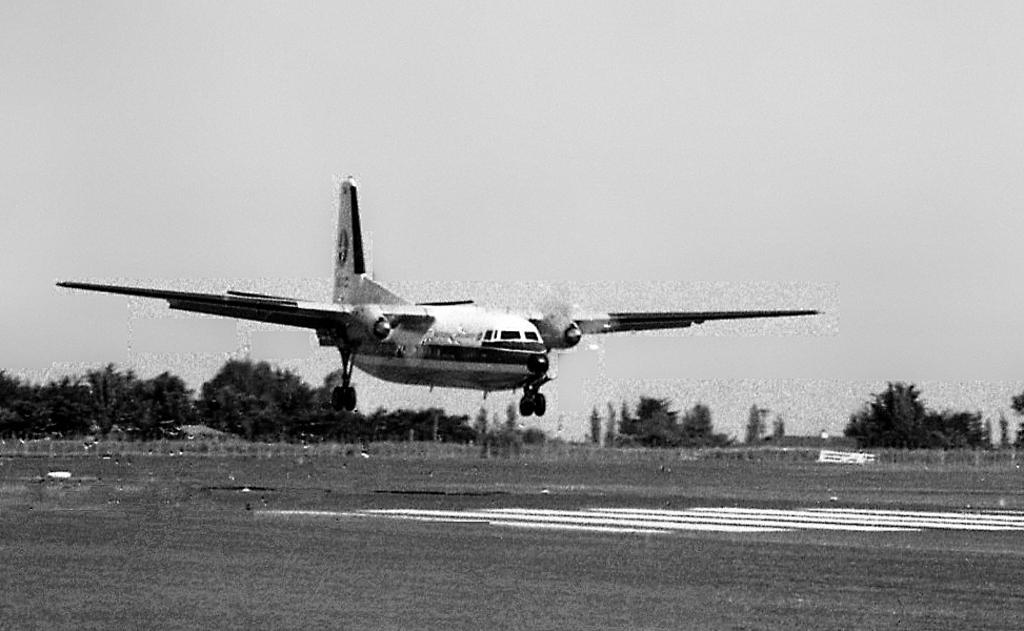What is the main subject of the image? The main subject of the image is an airplane. What is the airplane doing in the image? The airplane is landing on a runway. What type of natural elements can be seen in the image? There are trees in the image. What is visible in the background of the image? The sky is visible in the background of the image. How is the image presented in terms of color? The image is black and white. Can you see a giraffe rubbing against a coil in the image? No, there is no giraffe or coil present in the image. 